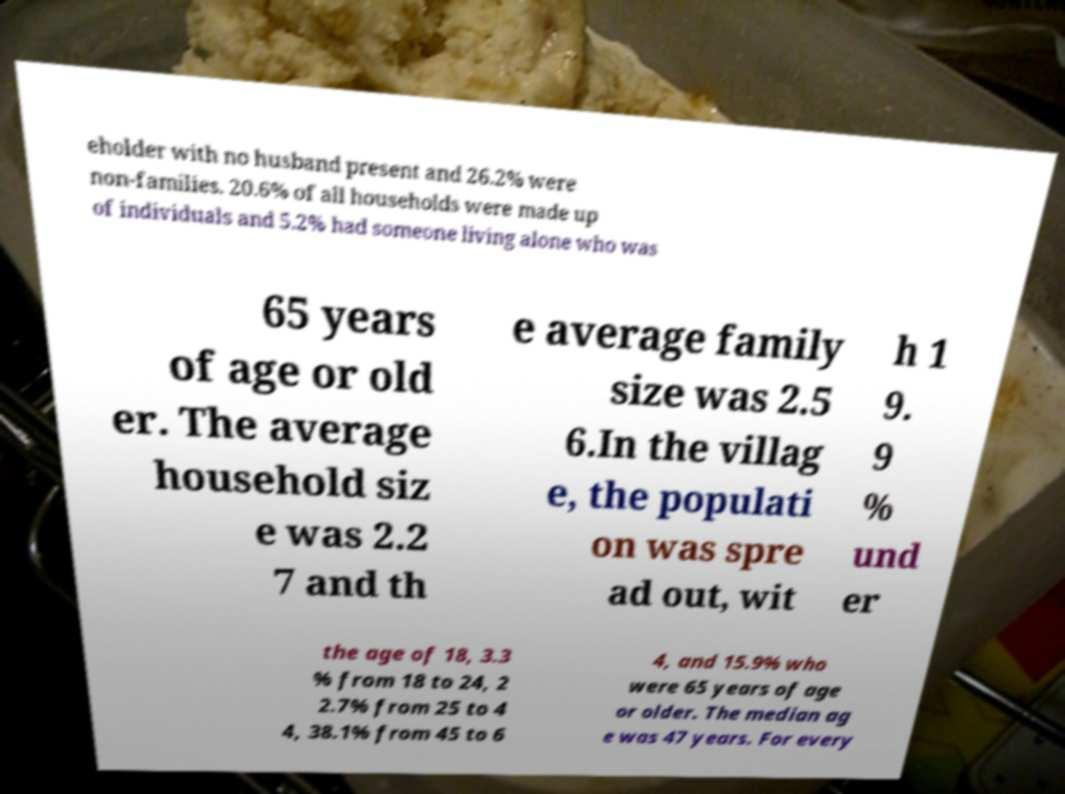For documentation purposes, I need the text within this image transcribed. Could you provide that? eholder with no husband present and 26.2% were non-families. 20.6% of all households were made up of individuals and 5.2% had someone living alone who was 65 years of age or old er. The average household siz e was 2.2 7 and th e average family size was 2.5 6.In the villag e, the populati on was spre ad out, wit h 1 9. 9 % und er the age of 18, 3.3 % from 18 to 24, 2 2.7% from 25 to 4 4, 38.1% from 45 to 6 4, and 15.9% who were 65 years of age or older. The median ag e was 47 years. For every 